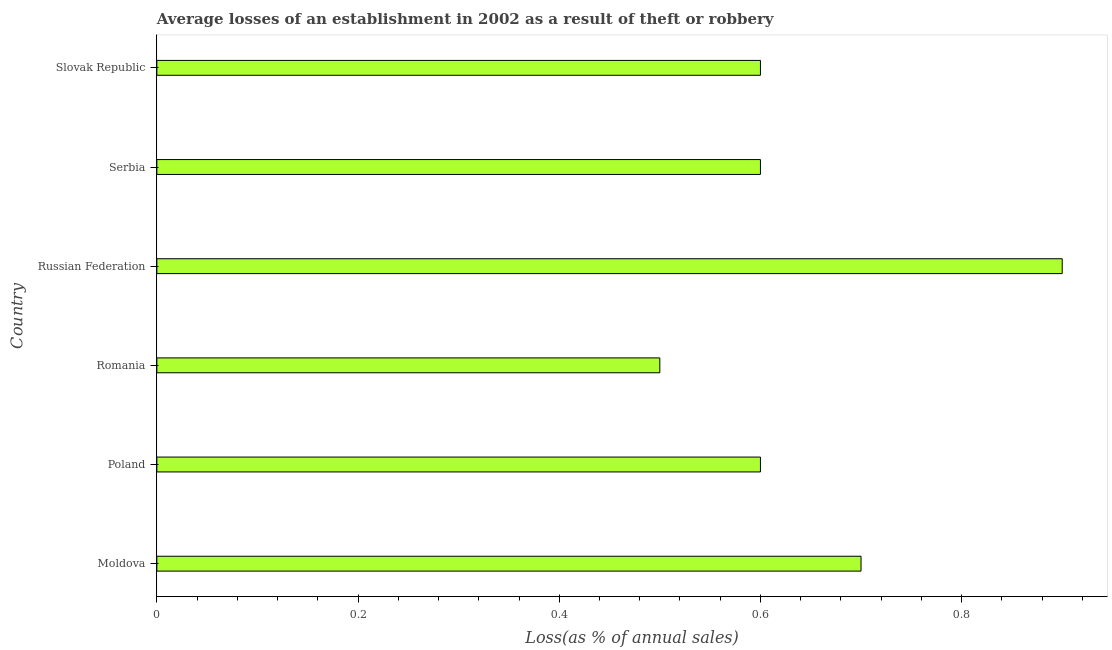What is the title of the graph?
Offer a terse response. Average losses of an establishment in 2002 as a result of theft or robbery. What is the label or title of the X-axis?
Offer a very short reply. Loss(as % of annual sales). What is the label or title of the Y-axis?
Ensure brevity in your answer.  Country. Across all countries, what is the minimum losses due to theft?
Your response must be concise. 0.5. In which country was the losses due to theft maximum?
Provide a short and direct response. Russian Federation. In which country was the losses due to theft minimum?
Ensure brevity in your answer.  Romania. What is the average losses due to theft per country?
Ensure brevity in your answer.  0.65. What is the ratio of the losses due to theft in Moldova to that in Serbia?
Provide a short and direct response. 1.17. Is the difference between the losses due to theft in Romania and Serbia greater than the difference between any two countries?
Your answer should be compact. No. Is the sum of the losses due to theft in Romania and Russian Federation greater than the maximum losses due to theft across all countries?
Keep it short and to the point. Yes. In how many countries, is the losses due to theft greater than the average losses due to theft taken over all countries?
Make the answer very short. 2. What is the Loss(as % of annual sales) in Poland?
Make the answer very short. 0.6. What is the Loss(as % of annual sales) of Romania?
Keep it short and to the point. 0.5. What is the Loss(as % of annual sales) of Slovak Republic?
Ensure brevity in your answer.  0.6. What is the difference between the Loss(as % of annual sales) in Moldova and Poland?
Give a very brief answer. 0.1. What is the difference between the Loss(as % of annual sales) in Moldova and Romania?
Make the answer very short. 0.2. What is the difference between the Loss(as % of annual sales) in Poland and Romania?
Keep it short and to the point. 0.1. What is the difference between the Loss(as % of annual sales) in Poland and Russian Federation?
Keep it short and to the point. -0.3. What is the difference between the Loss(as % of annual sales) in Poland and Slovak Republic?
Your response must be concise. 0. What is the difference between the Loss(as % of annual sales) in Romania and Russian Federation?
Offer a terse response. -0.4. What is the difference between the Loss(as % of annual sales) in Romania and Serbia?
Make the answer very short. -0.1. What is the difference between the Loss(as % of annual sales) in Serbia and Slovak Republic?
Offer a terse response. 0. What is the ratio of the Loss(as % of annual sales) in Moldova to that in Poland?
Give a very brief answer. 1.17. What is the ratio of the Loss(as % of annual sales) in Moldova to that in Romania?
Offer a very short reply. 1.4. What is the ratio of the Loss(as % of annual sales) in Moldova to that in Russian Federation?
Ensure brevity in your answer.  0.78. What is the ratio of the Loss(as % of annual sales) in Moldova to that in Serbia?
Your answer should be compact. 1.17. What is the ratio of the Loss(as % of annual sales) in Moldova to that in Slovak Republic?
Offer a very short reply. 1.17. What is the ratio of the Loss(as % of annual sales) in Poland to that in Romania?
Keep it short and to the point. 1.2. What is the ratio of the Loss(as % of annual sales) in Poland to that in Russian Federation?
Your answer should be very brief. 0.67. What is the ratio of the Loss(as % of annual sales) in Romania to that in Russian Federation?
Your answer should be very brief. 0.56. What is the ratio of the Loss(as % of annual sales) in Romania to that in Serbia?
Your answer should be compact. 0.83. What is the ratio of the Loss(as % of annual sales) in Romania to that in Slovak Republic?
Offer a very short reply. 0.83. What is the ratio of the Loss(as % of annual sales) in Russian Federation to that in Serbia?
Your answer should be very brief. 1.5. 